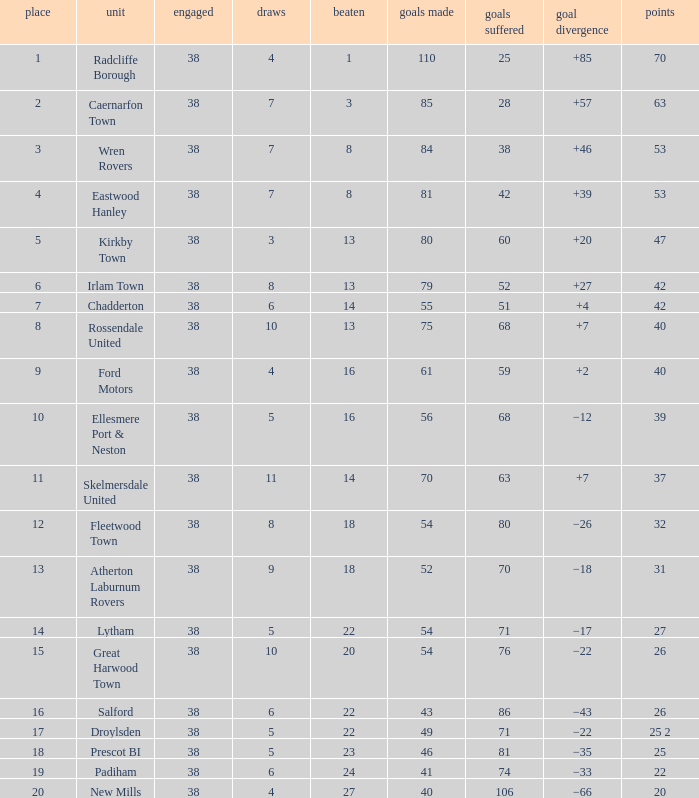Which Lost has a Position larger than 5, and Points 1 of 37, and less than 63 Goals Against? None. 